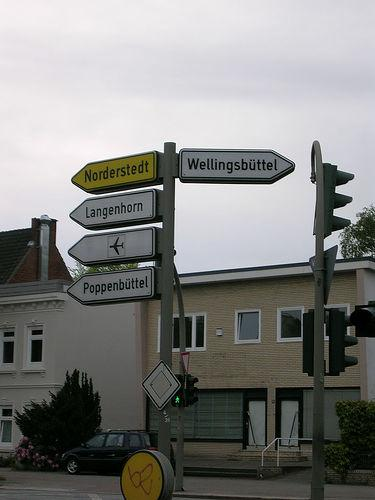Question: where was the picture taken?
Choices:
A. Hospital x-ray lab.
B. Disneyland.
C. At a baseball game.
D. Outside on the street.
Answer with the letter. Answer: D Question: who is standing in the picture?
Choices:
A. A mom and dad.
B. No one.
C. Elephant.
D. People on the bus.
Answer with the letter. Answer: B Question: what is the picture showing?
Choices:
A. People swimming.
B. Street signs.
C. Trains.
D. Trees.
Answer with the letter. Answer: B Question: why was the picture taken?
Choices:
A. To remember the event.
B. To understand the accident.
C. To capture the signs.
D. Because a tiger was walking down the street.
Answer with the letter. Answer: C Question: how many signs are in picture?
Choices:
A. One.
B. Seven.
C. Two.
D. Three.
Answer with the letter. Answer: B 